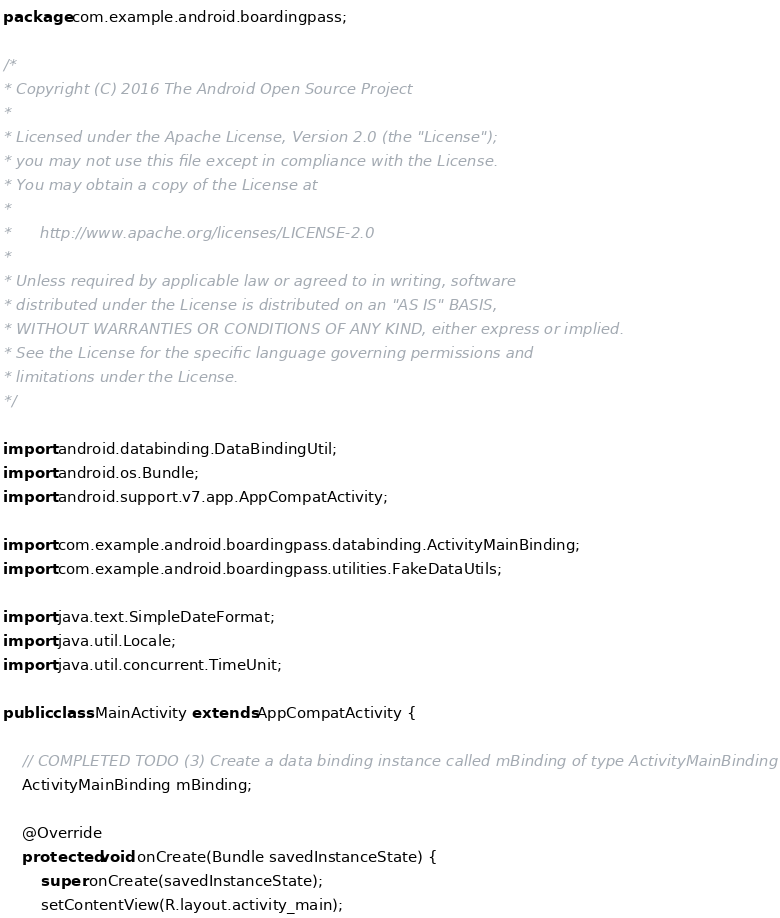Convert code to text. <code><loc_0><loc_0><loc_500><loc_500><_Java_>package com.example.android.boardingpass;

/*
* Copyright (C) 2016 The Android Open Source Project
*
* Licensed under the Apache License, Version 2.0 (the "License");
* you may not use this file except in compliance with the License.
* You may obtain a copy of the License at
*
*      http://www.apache.org/licenses/LICENSE-2.0
*
* Unless required by applicable law or agreed to in writing, software
* distributed under the License is distributed on an "AS IS" BASIS,
* WITHOUT WARRANTIES OR CONDITIONS OF ANY KIND, either express or implied.
* See the License for the specific language governing permissions and
* limitations under the License.
*/

import android.databinding.DataBindingUtil;
import android.os.Bundle;
import android.support.v7.app.AppCompatActivity;

import com.example.android.boardingpass.databinding.ActivityMainBinding;
import com.example.android.boardingpass.utilities.FakeDataUtils;

import java.text.SimpleDateFormat;
import java.util.Locale;
import java.util.concurrent.TimeUnit;

public class MainActivity extends AppCompatActivity {

    // COMPLETED TODO (3) Create a data binding instance called mBinding of type ActivityMainBinding
    ActivityMainBinding mBinding;

    @Override
    protected void onCreate(Bundle savedInstanceState) {
        super.onCreate(savedInstanceState);
        setContentView(R.layout.activity_main);

</code> 